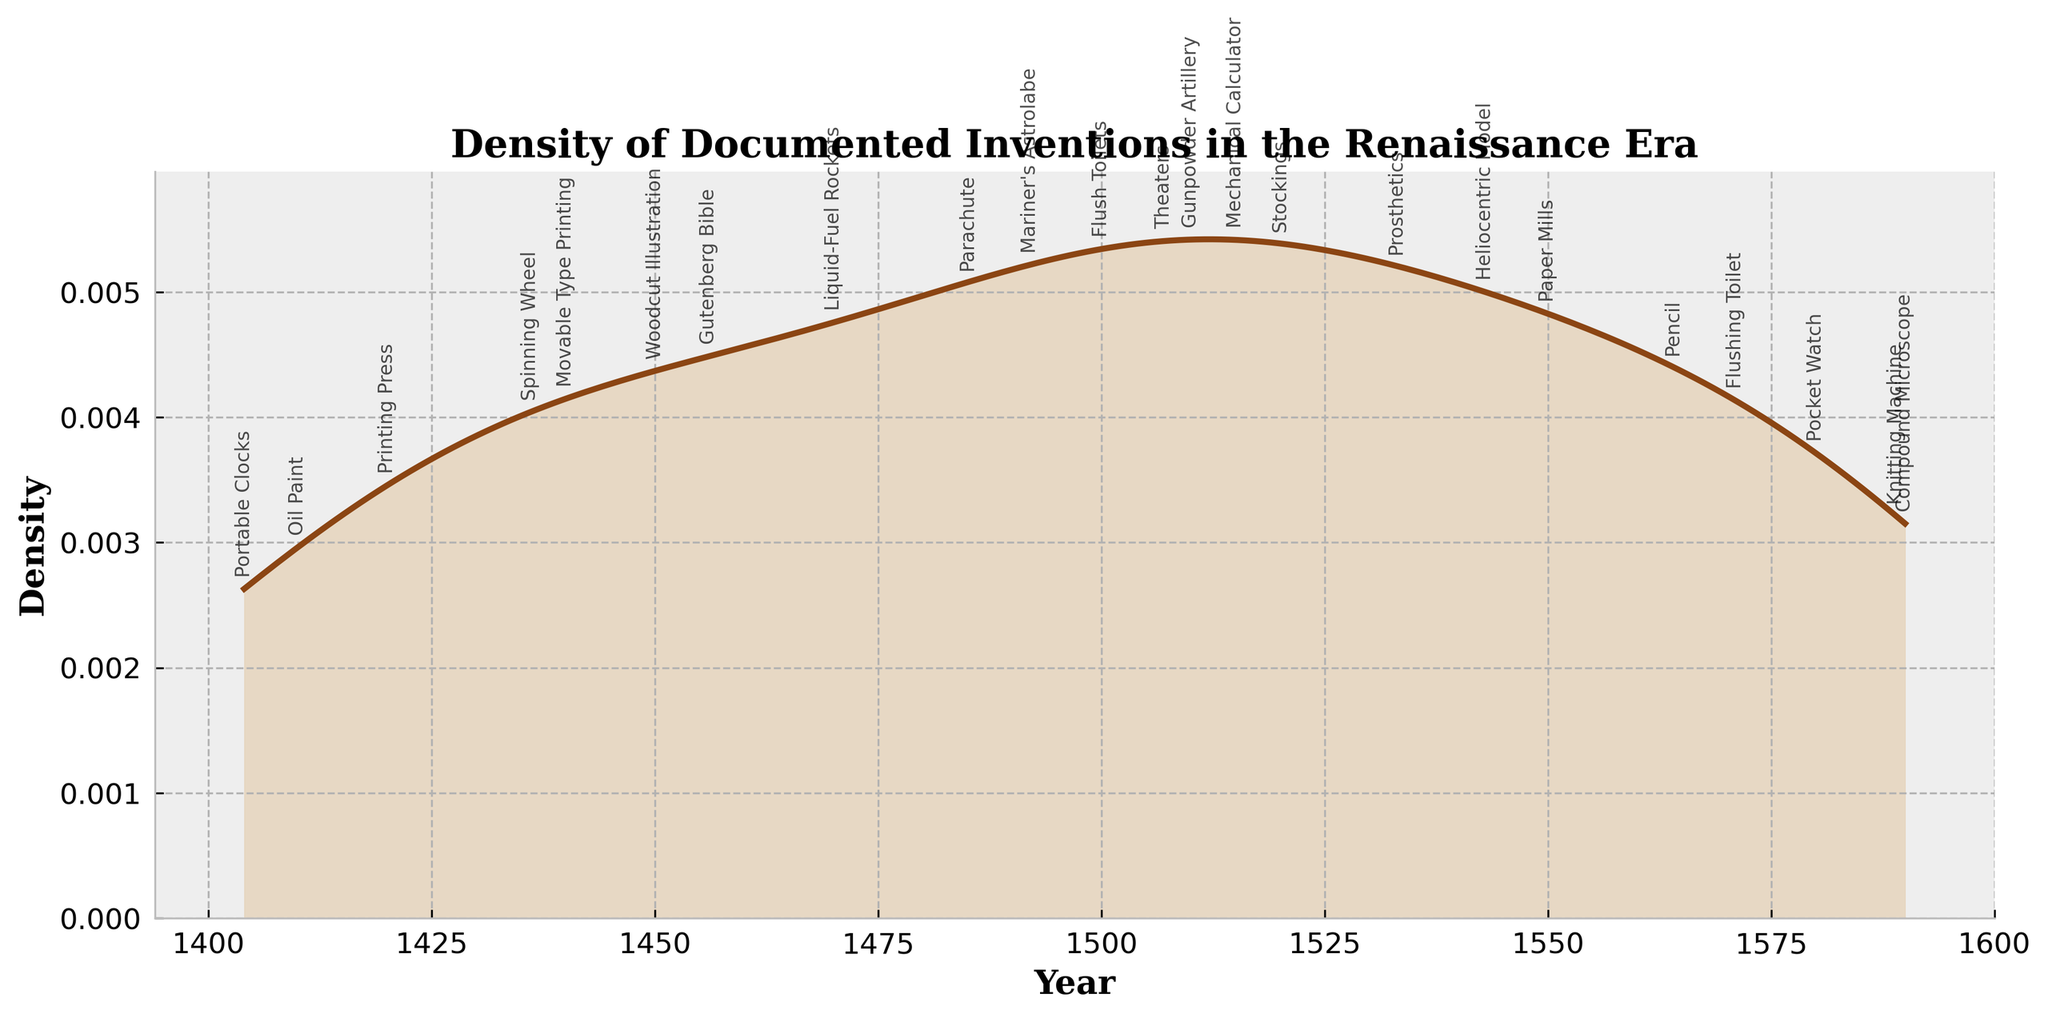When was the peak density of documented inventions during the Renaissance era? To determine this, look for the highest point on the density curve. This peak represents the year with the most significant concentration of documented inventions.
Answer: Around 1550 What is the title of the figure? The title typically is located at the top of the figure and provides a summary of what the plot represents.
Answer: Density of Documented Inventions in the Renaissance Era How many distinct years of documented inventions are presented in the plot? Count the unique years annotated on the plot, which represent specific points where an invention was documented.
Answer: 24 Which year has the lowest density of documented inventions and what invention is associated with it? Identify the lowest points on the density curve and check the annotated invention next to or at those points.
Answer: 1485, Parachute Which invention in the plot is closest in density to the year 1500? Look at the density value around the year 1500 and identify the closest annotated inventions.
Answer: Gunpowder Artillery Are there any periods with a noticeable lack of documented inventions? Examine the plot for flat or near-zero density segments, indicating periods with sparse or no documented inventions.
Answer: Around 1460-1470 Compare the density of documented inventions between 1450 and 1500. Did it increase, decrease, or stay constant? Analyze the shape of the density curve between 1450 and 1500 to determine if the value increased, decreased, or remained constant during this period.
Answer: Increased Between which years does the most significant rise in the density of documented inventions occur? Identify the steepest ascending part of the curve and get the year range at this segment.
Answer: Between 1550 and 1570 What does the y-axis represent in this figure? Look at the y-axis label which typically describes what is being measured on this axis.
Answer: Density Is the documented invention "Oil Paint" closer to the beginning or the end of the Renaissance period as indicated in the plot? Check the position of the annotation "Oil Paint" relative to the start and end years of the plotted data.
Answer: Beginning 